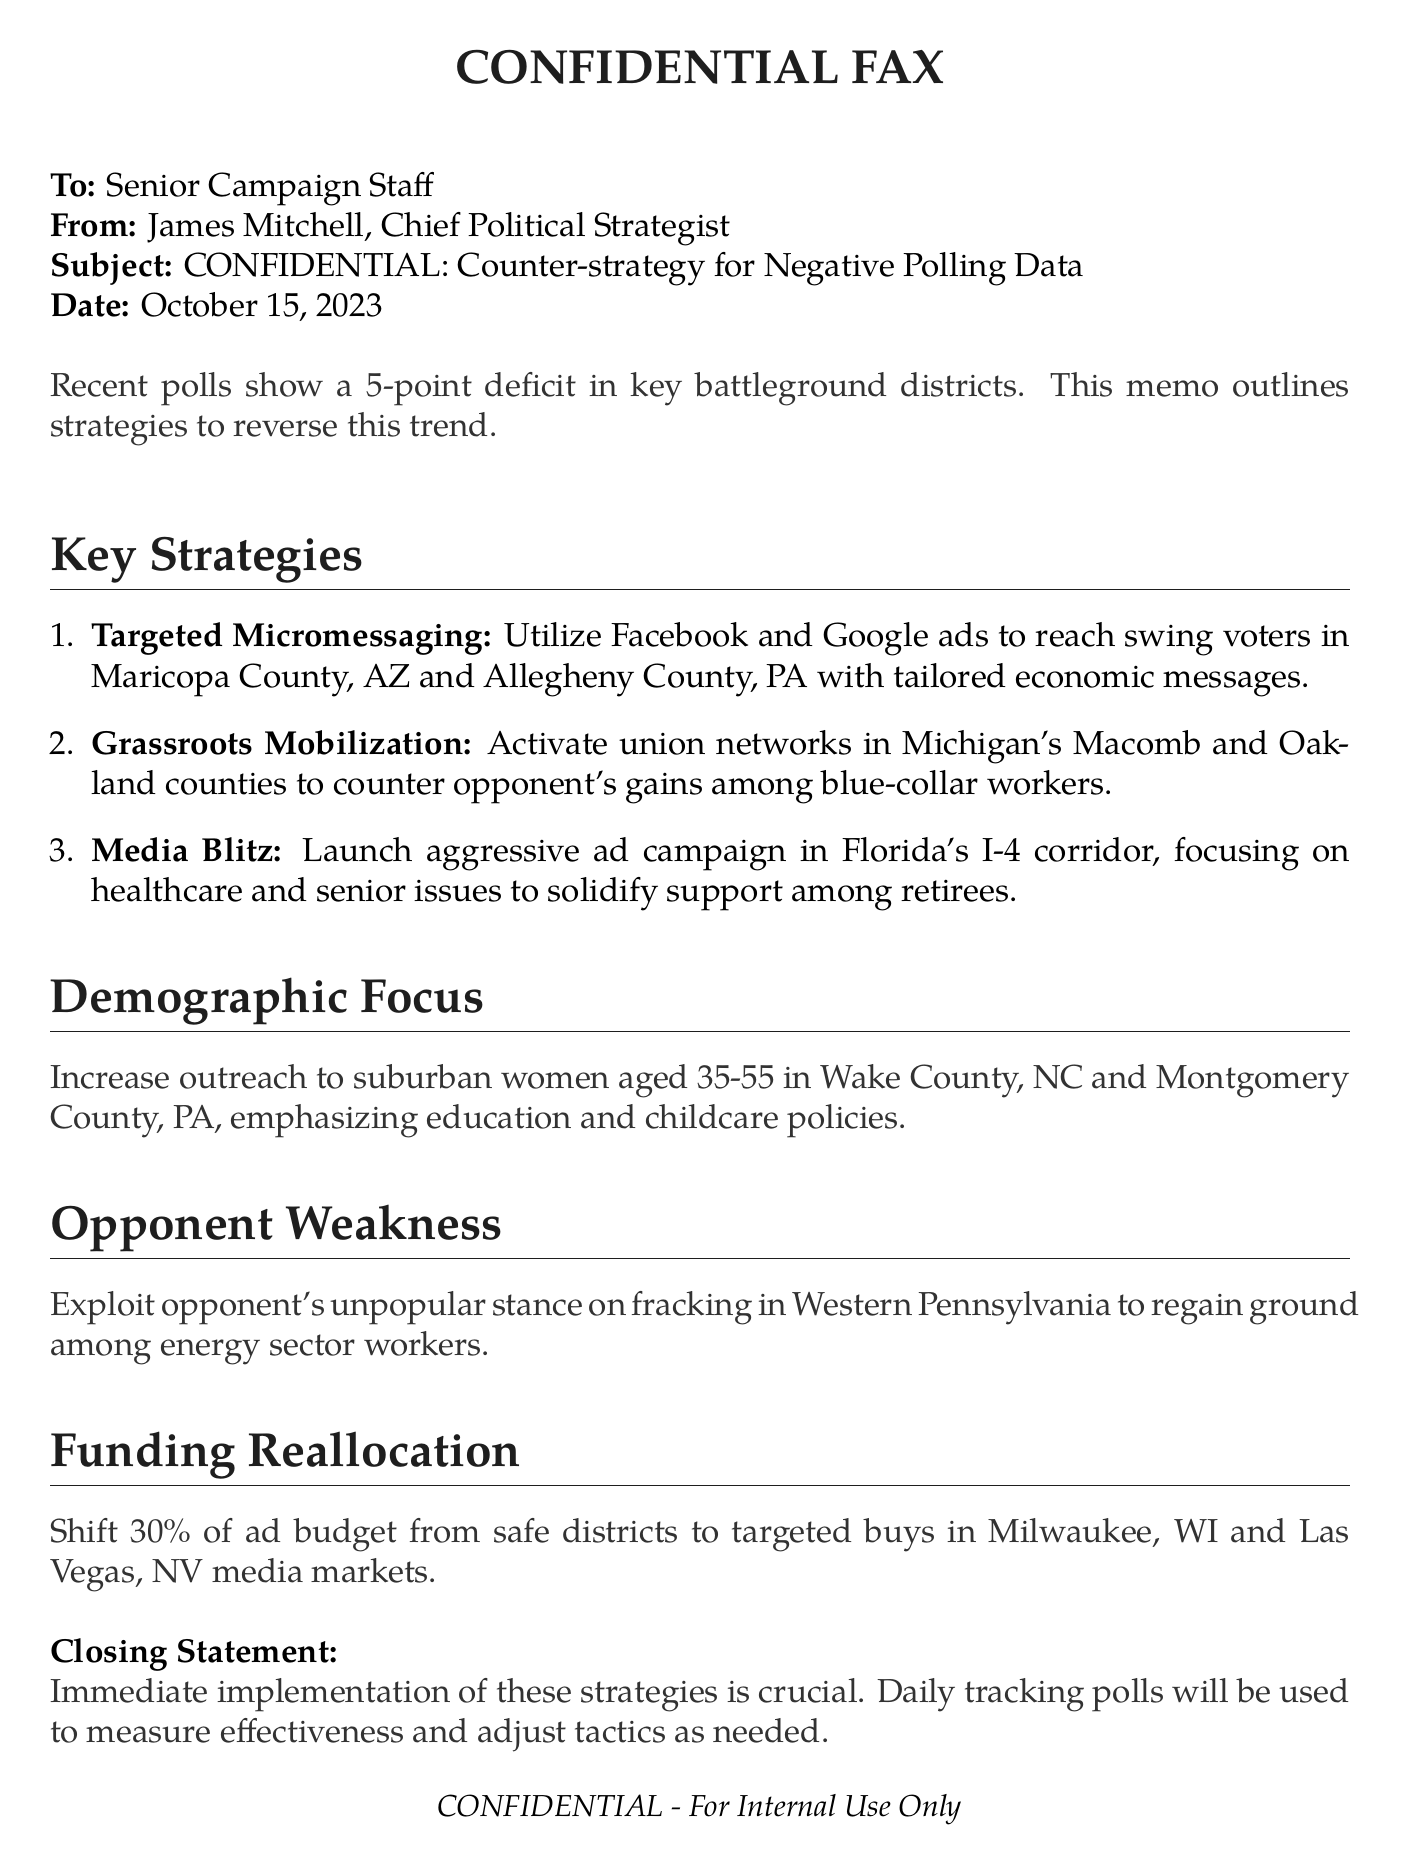What is the date of the memo? The date of the memo is stated at the top, which indicates when it was written.
Answer: October 15, 2023 Who is the sender of the fax? The sender of the fax is mentioned at the beginning, providing insight into the authority behind the memo.
Answer: James Mitchell What counties are targeted for micromessaging? The counties are specified in the strategies section, highlighting the focus areas for campaigning.
Answer: Maricopa County, AZ and Allegheny County, PA What percentage of the ad budget will be reallocated? The document states a specific percentage regarding funding changes to target crucial areas.
Answer: 30% What demographic group is emphasized for outreach? This detail is included under the demographic focus, specifying a key audience to engage in the campaign.
Answer: Suburban women aged 35-55 What is the main focus of the media blitz strategy? The focus is directly outlined in the media blitz section, showing what issues to concentrate on during the campaign.
Answer: Healthcare and senior issues In which district should grassroots mobilization be activated? The specific counties mentioned for grassroots efforts indicate where action should be taken to counter opponents.
Answer: Macomb and Oakland counties What issue should be exploited from the opponent's stance? The document identifies a weakness to capitalize on, guiding strategic campaigning actions.
Answer: Unpopular stance on fracking What does the closing statement emphasize? The concluding remarks outline the urgency of implementing the described strategies and monitoring their effectiveness.
Answer: Immediate implementation of these strategies 